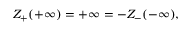<formula> <loc_0><loc_0><loc_500><loc_500>Z _ { + } ( + \infty ) = + \infty = - Z _ { - } ( - \infty ) ,</formula> 